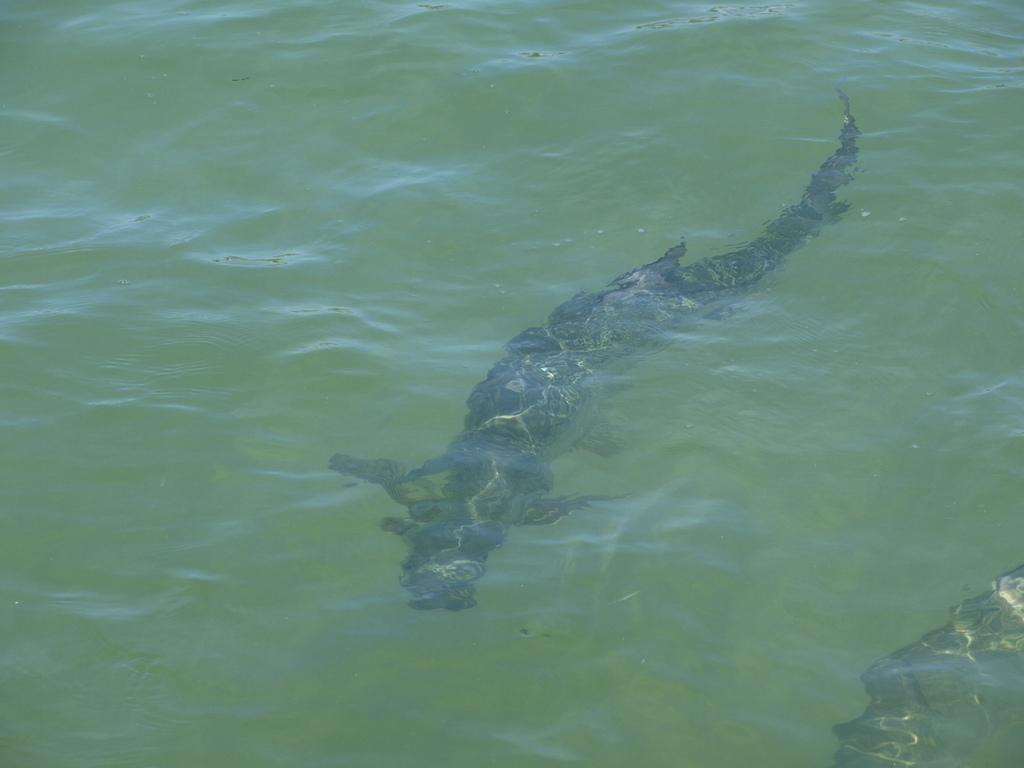What is the main subject of the image? There is an animal in the water in the image. Can you describe the animal's location in the image? The animal is in the water. What type of environment is depicted in the image? The image shows a water environment. What type of snow can be seen falling on the animal in the image? There is no snow present in the image; it depicts an animal in the water. What type of work is the animal doing in the image? The image does not show the animal performing any work; it is simply depicted in the water. 